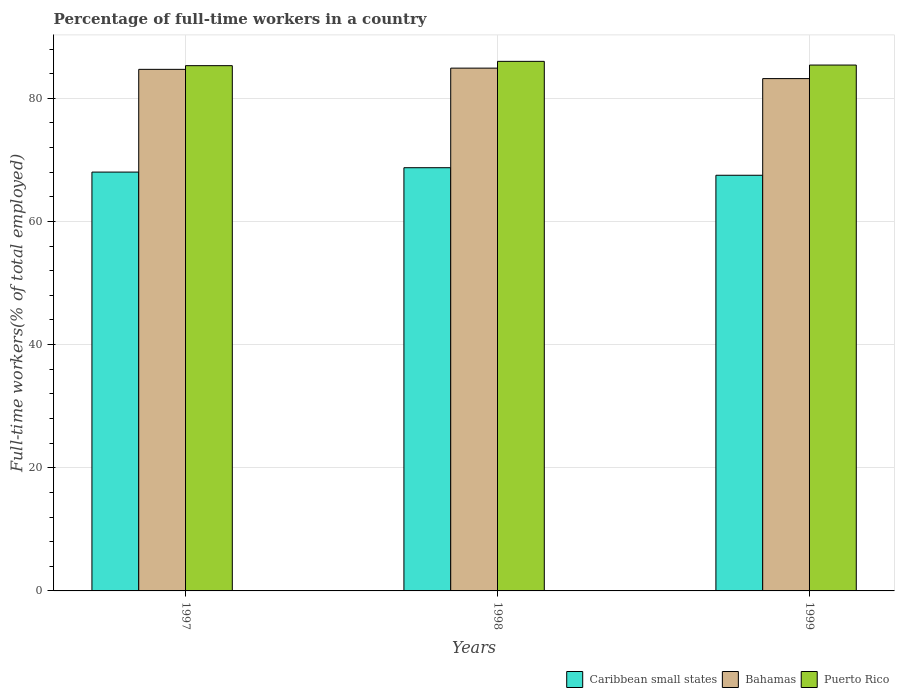How many different coloured bars are there?
Your answer should be very brief. 3. Are the number of bars per tick equal to the number of legend labels?
Your response must be concise. Yes. Are the number of bars on each tick of the X-axis equal?
Ensure brevity in your answer.  Yes. How many bars are there on the 2nd tick from the left?
Give a very brief answer. 3. How many bars are there on the 3rd tick from the right?
Offer a very short reply. 3. What is the percentage of full-time workers in Puerto Rico in 1999?
Ensure brevity in your answer.  85.4. Across all years, what is the maximum percentage of full-time workers in Bahamas?
Provide a succinct answer. 84.9. Across all years, what is the minimum percentage of full-time workers in Caribbean small states?
Provide a short and direct response. 67.5. In which year was the percentage of full-time workers in Puerto Rico minimum?
Offer a very short reply. 1997. What is the total percentage of full-time workers in Puerto Rico in the graph?
Your answer should be compact. 256.7. What is the difference between the percentage of full-time workers in Caribbean small states in 1997 and that in 1999?
Make the answer very short. 0.52. What is the difference between the percentage of full-time workers in Caribbean small states in 1997 and the percentage of full-time workers in Bahamas in 1999?
Provide a short and direct response. -15.18. What is the average percentage of full-time workers in Puerto Rico per year?
Keep it short and to the point. 85.57. In the year 1998, what is the difference between the percentage of full-time workers in Bahamas and percentage of full-time workers in Puerto Rico?
Provide a succinct answer. -1.1. In how many years, is the percentage of full-time workers in Caribbean small states greater than 40 %?
Your answer should be compact. 3. What is the ratio of the percentage of full-time workers in Caribbean small states in 1998 to that in 1999?
Keep it short and to the point. 1.02. Is the difference between the percentage of full-time workers in Bahamas in 1998 and 1999 greater than the difference between the percentage of full-time workers in Puerto Rico in 1998 and 1999?
Keep it short and to the point. Yes. What is the difference between the highest and the second highest percentage of full-time workers in Caribbean small states?
Keep it short and to the point. 0.71. What is the difference between the highest and the lowest percentage of full-time workers in Bahamas?
Give a very brief answer. 1.7. In how many years, is the percentage of full-time workers in Caribbean small states greater than the average percentage of full-time workers in Caribbean small states taken over all years?
Provide a short and direct response. 1. Is the sum of the percentage of full-time workers in Caribbean small states in 1997 and 1999 greater than the maximum percentage of full-time workers in Puerto Rico across all years?
Provide a short and direct response. Yes. What does the 1st bar from the left in 1999 represents?
Offer a terse response. Caribbean small states. What does the 2nd bar from the right in 1999 represents?
Ensure brevity in your answer.  Bahamas. Is it the case that in every year, the sum of the percentage of full-time workers in Puerto Rico and percentage of full-time workers in Bahamas is greater than the percentage of full-time workers in Caribbean small states?
Your response must be concise. Yes. Are all the bars in the graph horizontal?
Offer a very short reply. No. What is the difference between two consecutive major ticks on the Y-axis?
Make the answer very short. 20. Are the values on the major ticks of Y-axis written in scientific E-notation?
Offer a very short reply. No. Does the graph contain any zero values?
Keep it short and to the point. No. How many legend labels are there?
Your answer should be very brief. 3. How are the legend labels stacked?
Keep it short and to the point. Horizontal. What is the title of the graph?
Keep it short and to the point. Percentage of full-time workers in a country. What is the label or title of the X-axis?
Ensure brevity in your answer.  Years. What is the label or title of the Y-axis?
Your answer should be compact. Full-time workers(% of total employed). What is the Full-time workers(% of total employed) in Caribbean small states in 1997?
Your answer should be compact. 68.02. What is the Full-time workers(% of total employed) in Bahamas in 1997?
Provide a succinct answer. 84.7. What is the Full-time workers(% of total employed) of Puerto Rico in 1997?
Provide a succinct answer. 85.3. What is the Full-time workers(% of total employed) of Caribbean small states in 1998?
Make the answer very short. 68.73. What is the Full-time workers(% of total employed) of Bahamas in 1998?
Give a very brief answer. 84.9. What is the Full-time workers(% of total employed) in Puerto Rico in 1998?
Ensure brevity in your answer.  86. What is the Full-time workers(% of total employed) in Caribbean small states in 1999?
Offer a very short reply. 67.5. What is the Full-time workers(% of total employed) in Bahamas in 1999?
Offer a terse response. 83.2. What is the Full-time workers(% of total employed) of Puerto Rico in 1999?
Keep it short and to the point. 85.4. Across all years, what is the maximum Full-time workers(% of total employed) of Caribbean small states?
Your response must be concise. 68.73. Across all years, what is the maximum Full-time workers(% of total employed) in Bahamas?
Your answer should be very brief. 84.9. Across all years, what is the minimum Full-time workers(% of total employed) of Caribbean small states?
Make the answer very short. 67.5. Across all years, what is the minimum Full-time workers(% of total employed) of Bahamas?
Your response must be concise. 83.2. Across all years, what is the minimum Full-time workers(% of total employed) of Puerto Rico?
Your response must be concise. 85.3. What is the total Full-time workers(% of total employed) of Caribbean small states in the graph?
Your answer should be compact. 204.25. What is the total Full-time workers(% of total employed) in Bahamas in the graph?
Keep it short and to the point. 252.8. What is the total Full-time workers(% of total employed) of Puerto Rico in the graph?
Offer a very short reply. 256.7. What is the difference between the Full-time workers(% of total employed) of Caribbean small states in 1997 and that in 1998?
Your answer should be very brief. -0.71. What is the difference between the Full-time workers(% of total employed) in Caribbean small states in 1997 and that in 1999?
Your answer should be compact. 0.52. What is the difference between the Full-time workers(% of total employed) in Bahamas in 1997 and that in 1999?
Keep it short and to the point. 1.5. What is the difference between the Full-time workers(% of total employed) of Puerto Rico in 1997 and that in 1999?
Your answer should be very brief. -0.1. What is the difference between the Full-time workers(% of total employed) of Caribbean small states in 1998 and that in 1999?
Your answer should be very brief. 1.23. What is the difference between the Full-time workers(% of total employed) of Bahamas in 1998 and that in 1999?
Your answer should be compact. 1.7. What is the difference between the Full-time workers(% of total employed) of Puerto Rico in 1998 and that in 1999?
Give a very brief answer. 0.6. What is the difference between the Full-time workers(% of total employed) in Caribbean small states in 1997 and the Full-time workers(% of total employed) in Bahamas in 1998?
Give a very brief answer. -16.88. What is the difference between the Full-time workers(% of total employed) in Caribbean small states in 1997 and the Full-time workers(% of total employed) in Puerto Rico in 1998?
Provide a succinct answer. -17.98. What is the difference between the Full-time workers(% of total employed) in Caribbean small states in 1997 and the Full-time workers(% of total employed) in Bahamas in 1999?
Offer a terse response. -15.18. What is the difference between the Full-time workers(% of total employed) of Caribbean small states in 1997 and the Full-time workers(% of total employed) of Puerto Rico in 1999?
Ensure brevity in your answer.  -17.38. What is the difference between the Full-time workers(% of total employed) in Bahamas in 1997 and the Full-time workers(% of total employed) in Puerto Rico in 1999?
Give a very brief answer. -0.7. What is the difference between the Full-time workers(% of total employed) of Caribbean small states in 1998 and the Full-time workers(% of total employed) of Bahamas in 1999?
Make the answer very short. -14.47. What is the difference between the Full-time workers(% of total employed) in Caribbean small states in 1998 and the Full-time workers(% of total employed) in Puerto Rico in 1999?
Make the answer very short. -16.67. What is the average Full-time workers(% of total employed) in Caribbean small states per year?
Your answer should be compact. 68.08. What is the average Full-time workers(% of total employed) in Bahamas per year?
Provide a succinct answer. 84.27. What is the average Full-time workers(% of total employed) in Puerto Rico per year?
Your response must be concise. 85.57. In the year 1997, what is the difference between the Full-time workers(% of total employed) in Caribbean small states and Full-time workers(% of total employed) in Bahamas?
Give a very brief answer. -16.68. In the year 1997, what is the difference between the Full-time workers(% of total employed) of Caribbean small states and Full-time workers(% of total employed) of Puerto Rico?
Offer a terse response. -17.28. In the year 1997, what is the difference between the Full-time workers(% of total employed) of Bahamas and Full-time workers(% of total employed) of Puerto Rico?
Your answer should be compact. -0.6. In the year 1998, what is the difference between the Full-time workers(% of total employed) of Caribbean small states and Full-time workers(% of total employed) of Bahamas?
Your answer should be very brief. -16.17. In the year 1998, what is the difference between the Full-time workers(% of total employed) in Caribbean small states and Full-time workers(% of total employed) in Puerto Rico?
Your answer should be compact. -17.27. In the year 1998, what is the difference between the Full-time workers(% of total employed) in Bahamas and Full-time workers(% of total employed) in Puerto Rico?
Offer a terse response. -1.1. In the year 1999, what is the difference between the Full-time workers(% of total employed) in Caribbean small states and Full-time workers(% of total employed) in Bahamas?
Keep it short and to the point. -15.7. In the year 1999, what is the difference between the Full-time workers(% of total employed) in Caribbean small states and Full-time workers(% of total employed) in Puerto Rico?
Your answer should be compact. -17.9. What is the ratio of the Full-time workers(% of total employed) of Bahamas in 1997 to that in 1998?
Your answer should be very brief. 1. What is the ratio of the Full-time workers(% of total employed) in Puerto Rico in 1997 to that in 1998?
Ensure brevity in your answer.  0.99. What is the ratio of the Full-time workers(% of total employed) in Caribbean small states in 1997 to that in 1999?
Your response must be concise. 1.01. What is the ratio of the Full-time workers(% of total employed) in Caribbean small states in 1998 to that in 1999?
Provide a short and direct response. 1.02. What is the ratio of the Full-time workers(% of total employed) of Bahamas in 1998 to that in 1999?
Provide a succinct answer. 1.02. What is the ratio of the Full-time workers(% of total employed) of Puerto Rico in 1998 to that in 1999?
Your response must be concise. 1.01. What is the difference between the highest and the second highest Full-time workers(% of total employed) in Caribbean small states?
Provide a short and direct response. 0.71. What is the difference between the highest and the second highest Full-time workers(% of total employed) in Bahamas?
Provide a short and direct response. 0.2. What is the difference between the highest and the lowest Full-time workers(% of total employed) of Caribbean small states?
Ensure brevity in your answer.  1.23. What is the difference between the highest and the lowest Full-time workers(% of total employed) in Bahamas?
Provide a succinct answer. 1.7. 